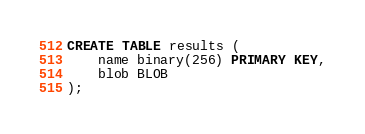<code> <loc_0><loc_0><loc_500><loc_500><_SQL_>CREATE TABLE results (
	name binary(256) PRIMARY KEY,
	blob BLOB
);</code> 